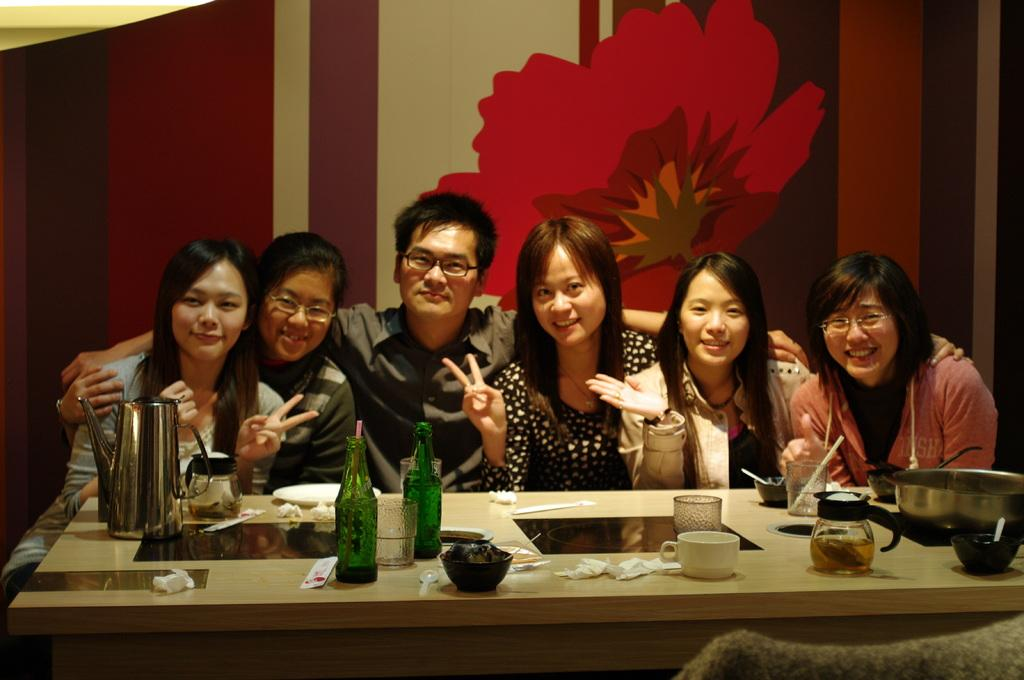How many people are in the image? There is a man and some women in the image, so there are multiple people present. What are the people in the image doing? The people are sitting in the image. Can you describe the expressions of the people in the image? Some people in the image are smiling. What type of accessories can be seen on some people in the image? Some people in the image are wearing glasses. What objects are on the table in the image? There are cups, bottles, and napkins on the table in the image. How many tomatoes are on the table in the image? There are no tomatoes present on the table in the image. Can you tell me how the people in the image are maintaining their balance? The people in the image are sitting, so there is no need for them to maintain their balance in the way the question suggests. 